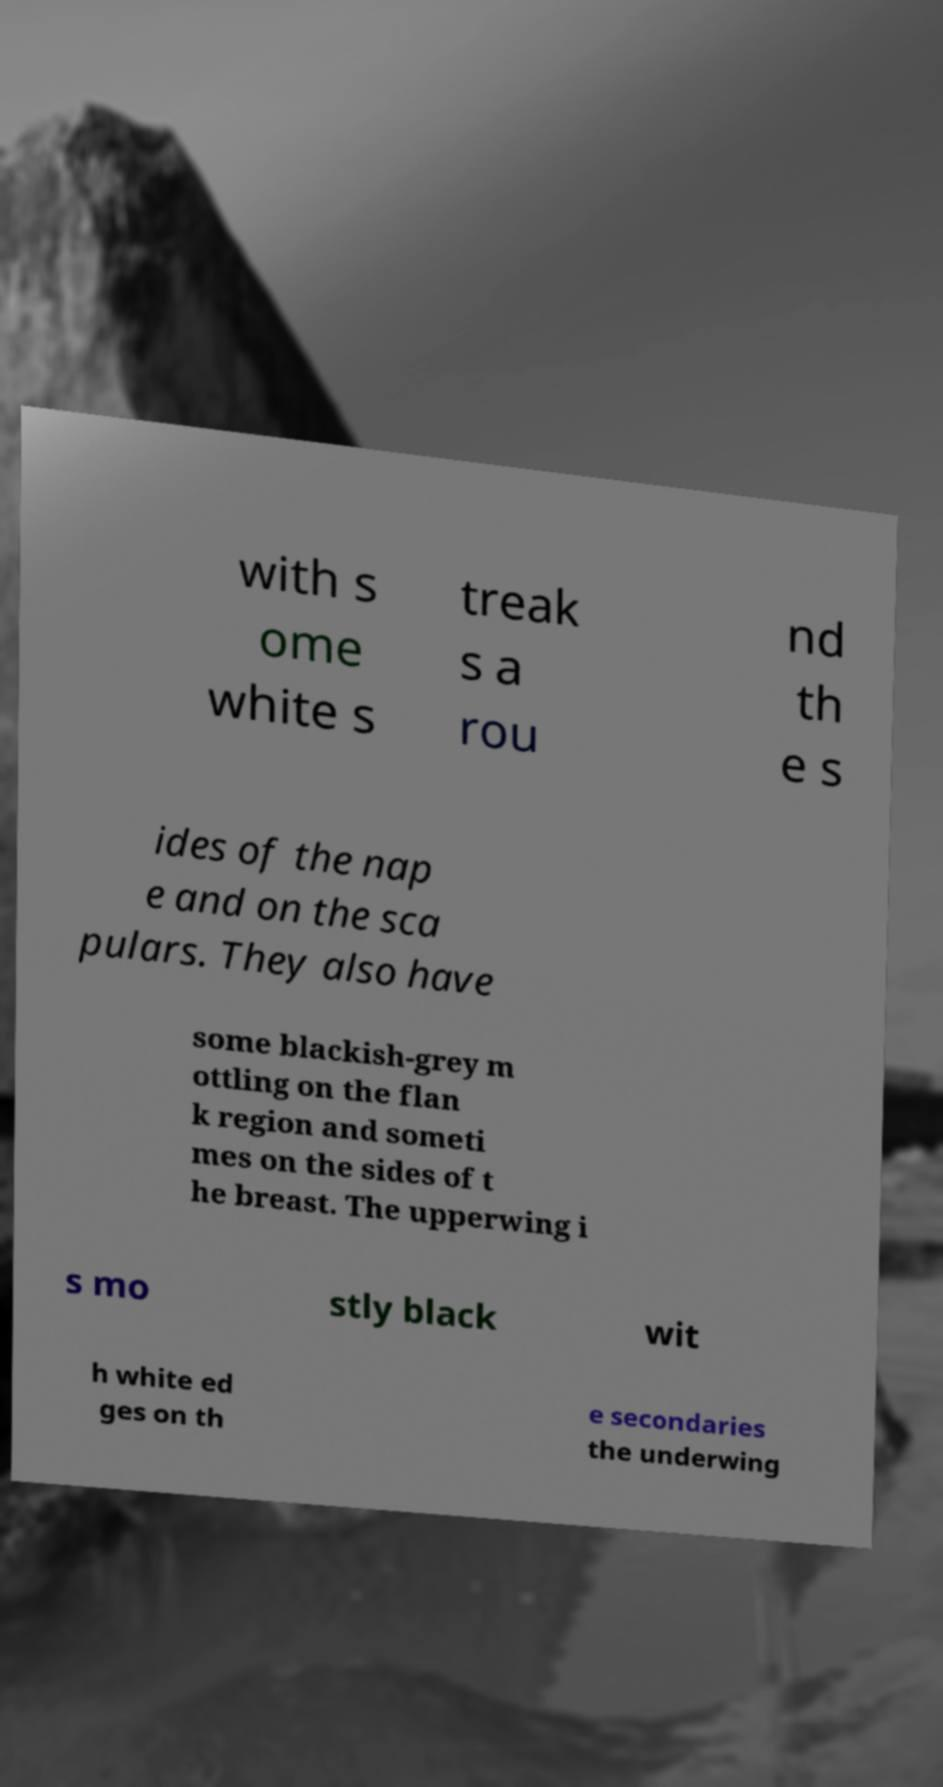What messages or text are displayed in this image? I need them in a readable, typed format. with s ome white s treak s a rou nd th e s ides of the nap e and on the sca pulars. They also have some blackish-grey m ottling on the flan k region and someti mes on the sides of t he breast. The upperwing i s mo stly black wit h white ed ges on th e secondaries the underwing 